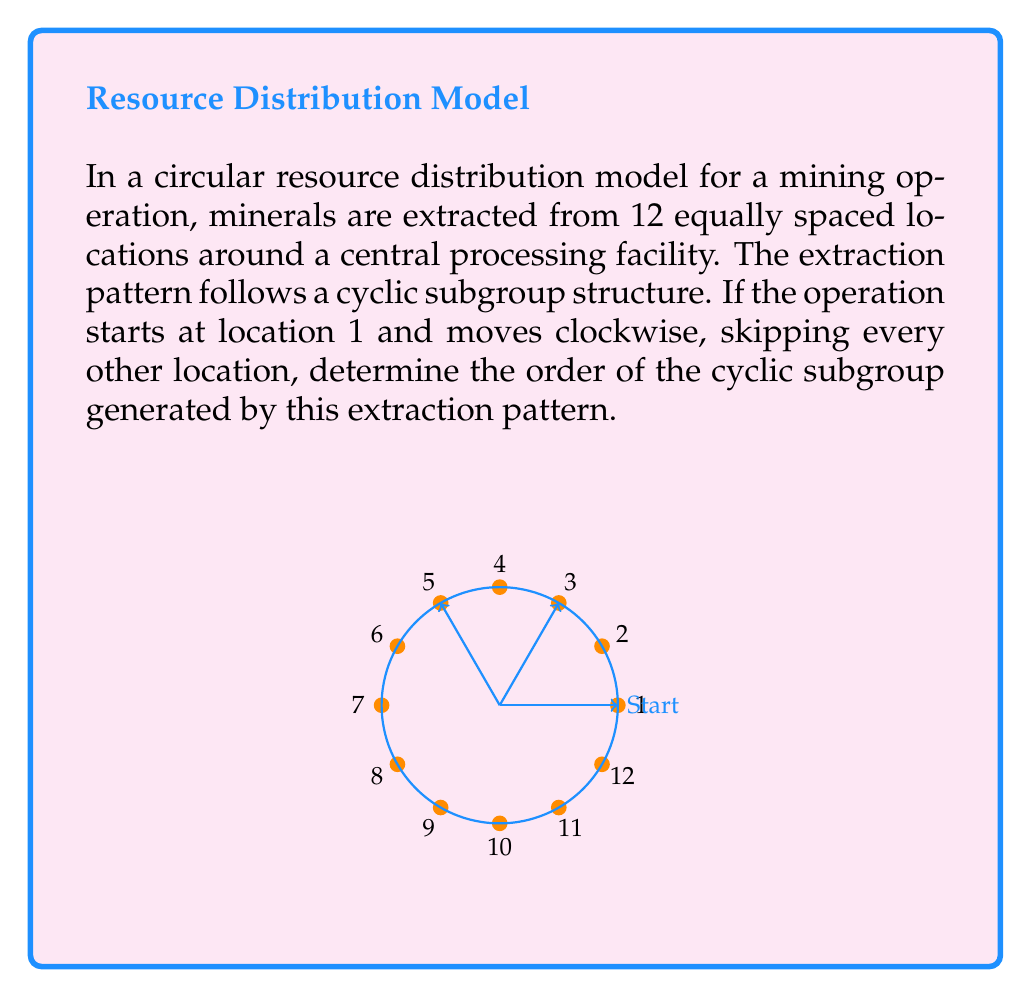Could you help me with this problem? To solve this problem, we need to follow these steps:

1) First, let's identify the pattern. Starting from location 1, we move clockwise, skipping every other location. This means we visit locations in the order: 1, 3, 5, 7, 9, 11.

2) In ring theory, this pattern forms a cyclic subgroup of the group of rotations of a 12-gon. Let's call the generator of this subgroup $a$.

3) To find the order of the cyclic subgroup, we need to determine how many times we need to apply the operation $a$ before we return to the starting point.

4) Let's list out the locations visited with each application of $a$:
   $a^1$: 1 → 3
   $a^2$: 3 → 5
   $a^3$: 5 → 7
   $a^4$: 7 → 9
   $a^5$: 9 → 11
   $a^6$: 11 → 1

5) We see that after 6 applications of $a$, we return to our starting point.

6) In mathematical terms, this means $a^6 = e$, where $e$ is the identity element of the group.

7) The order of an element in a group is the smallest positive integer $n$ such that $a^n = e$. In this case, that integer is 6.

Therefore, the order of the cyclic subgroup generated by this extraction pattern is 6.
Answer: 6 